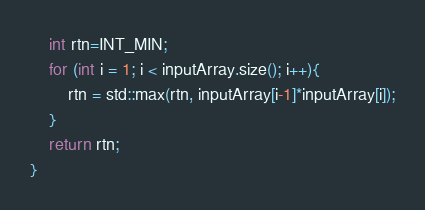<code> <loc_0><loc_0><loc_500><loc_500><_C++_>    int rtn=INT_MIN;
    for (int i = 1; i < inputArray.size(); i++){
        rtn = std::max(rtn, inputArray[i-1]*inputArray[i]);
    }
    return rtn;
}
</code> 